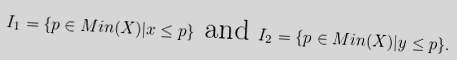<formula> <loc_0><loc_0><loc_500><loc_500>I _ { 1 } = \{ p \in M i n ( X ) | x \leq p \} \text { and } I _ { 2 } = \{ p \in M i n ( X ) | y \leq p \} .</formula> 